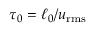<formula> <loc_0><loc_0><loc_500><loc_500>\tau _ { 0 } = \ell _ { 0 } / u _ { r m s }</formula> 